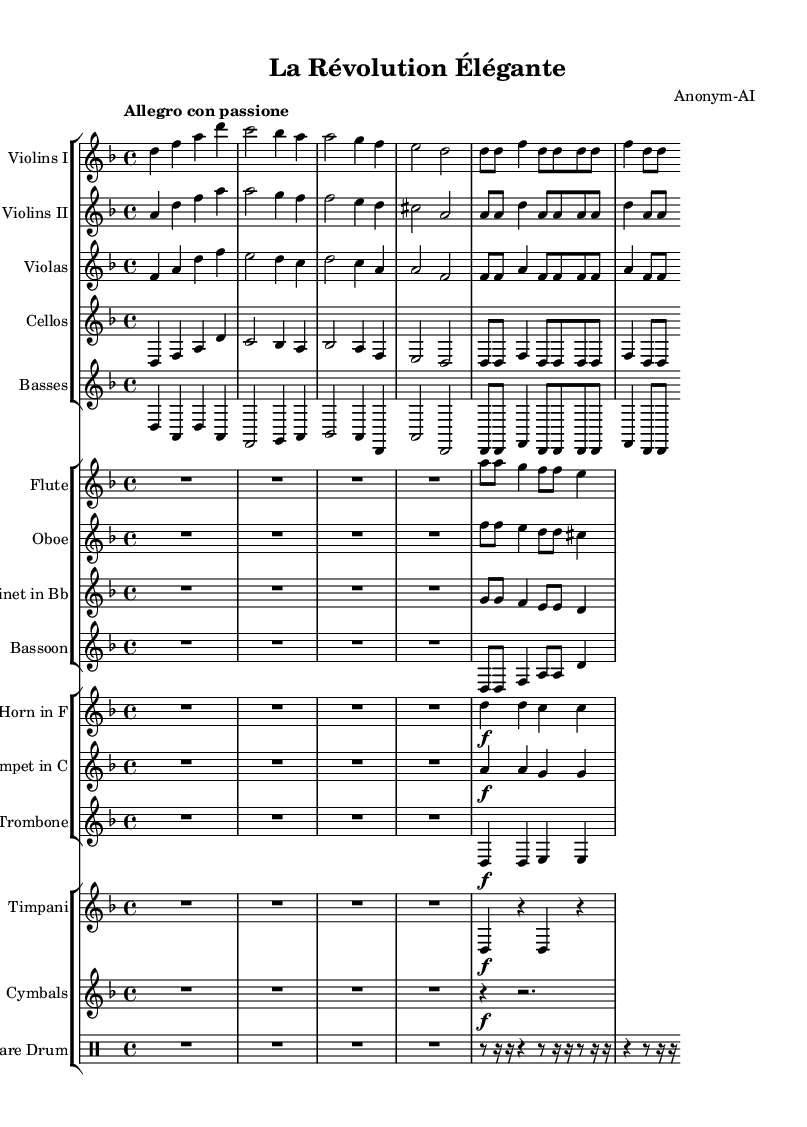What is the key signature of this music? The key signature is D minor, which has one flat (B flat). This can be identified from the key signature indicated at the beginning of the score.
Answer: D minor What is the time signature of this piece? The time signature shown at the beginning is 4/4, meaning there are four beats in each measure, and the quarter note gets the beat. This is clearly marked next to the key signature.
Answer: 4/4 What is the tempo marking for this symphony? The tempo marking is "Allegro con passione," which indicates a fast, lively tempo with passion. This can be found written above the score near the beginning.
Answer: Allegro con passione Which instrument plays the melody in the opening section? The opening melody is carried by the Violins I part, which plays the highest range of notes prominently throughout this section. This is determined by looking at the clef and note positions of the voices.
Answer: Violins I How many measures are repeated in the orchestration? The score shows a repeated section in several parts, indicated by "repeat unfold 2," which means that a total of 2 measures are intended to be repeated. This notation indicates how many times the preceding measures should be played again.
Answer: 2 What dynamic marking is indicated for the horn at the beginning? The dynamic marking for the horn part is marked as "f," indicating that it should be played forte, or loud. This is indicated at the start of the horn staff in the score.
Answer: f What is the role of the timpani in this symphonic piece? The timpani provides rhythmic support and accentuation, particularly in the lower range. The repeated notes and patterns indicate its role in punctuating rhythms and enhancing the overall orchestral texture. This can be inferred from examining the specific notes and their repetition throughout the measure.
Answer: Rhythmic support 